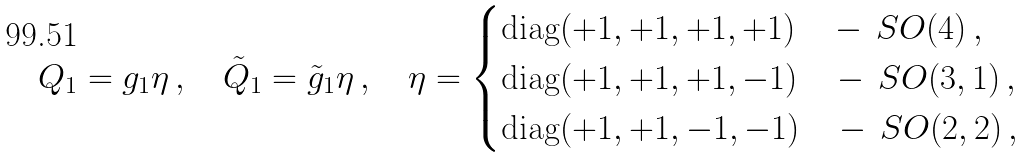Convert formula to latex. <formula><loc_0><loc_0><loc_500><loc_500>Q _ { 1 } = g _ { 1 } \eta \, , \quad { \tilde { Q } } _ { 1 } = { \tilde { g } } _ { 1 } \eta \, , \quad \eta = \begin{cases} \text {diag} ( + 1 , + 1 , + 1 , + 1 ) \quad - \, S O ( 4 ) \, , \\ \text {diag} ( + 1 , + 1 , + 1 , - 1 ) \quad - \, S O ( 3 , 1 ) \, , \\ \text {diag} ( + 1 , + 1 , - 1 , - 1 ) \quad - \, S O ( 2 , 2 ) \, , \\ \end{cases}</formula> 